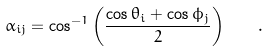Convert formula to latex. <formula><loc_0><loc_0><loc_500><loc_500>\alpha _ { i j } = \cos ^ { - 1 } { \left ( \frac { \cos { \theta _ { i } } + \cos { \phi _ { j } } } { 2 } \right ) } \quad .</formula> 